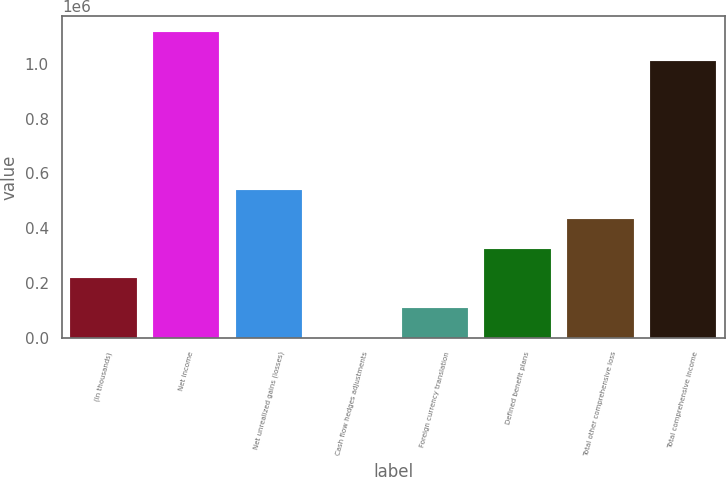Convert chart. <chart><loc_0><loc_0><loc_500><loc_500><bar_chart><fcel>(In thousands)<fcel>Net income<fcel>Net unrealized gains (losses)<fcel>Cash flow hedges adjustments<fcel>Foreign currency translation<fcel>Defined benefit plans<fcel>Total other comprehensive loss<fcel>Total comprehensive income<nl><fcel>216570<fcel>1.11692e+06<fcel>540232<fcel>796<fcel>108683<fcel>324457<fcel>432344<fcel>1.00903e+06<nl></chart> 